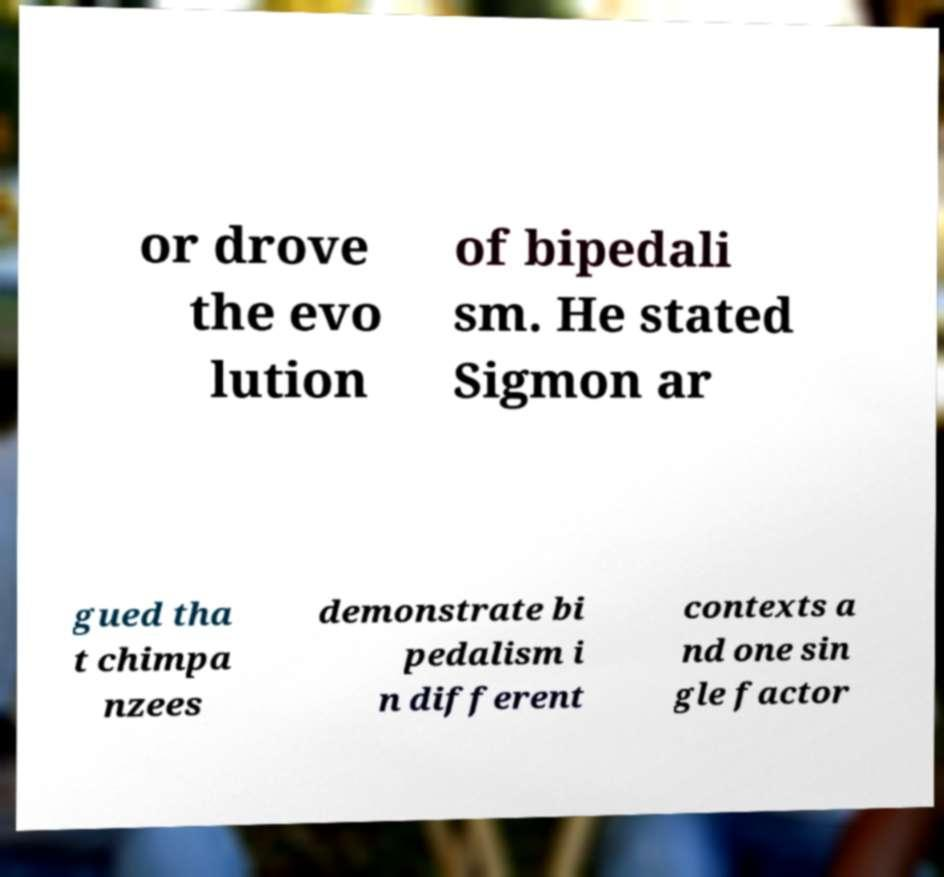Could you extract and type out the text from this image? or drove the evo lution of bipedali sm. He stated Sigmon ar gued tha t chimpa nzees demonstrate bi pedalism i n different contexts a nd one sin gle factor 